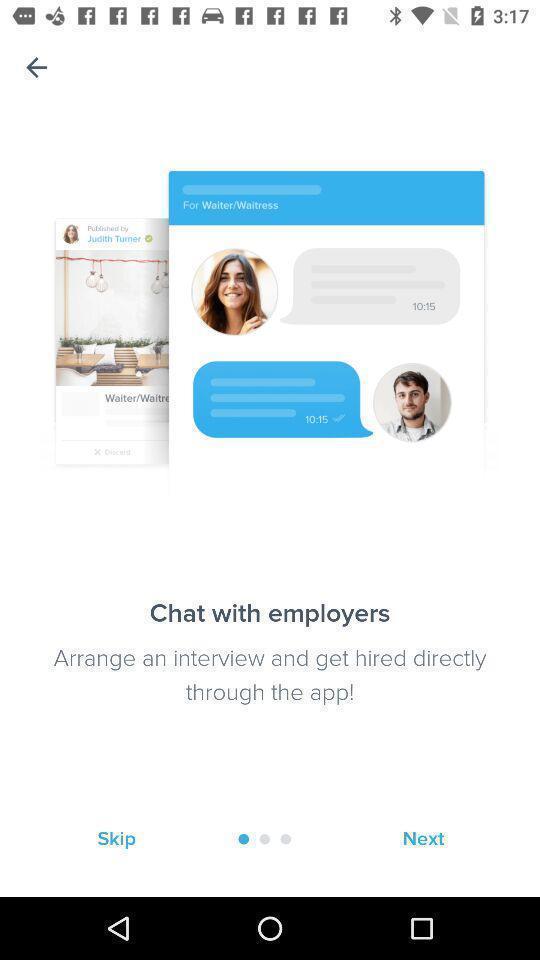What details can you identify in this image? Page shows to chat with interviewers in job finding app. 